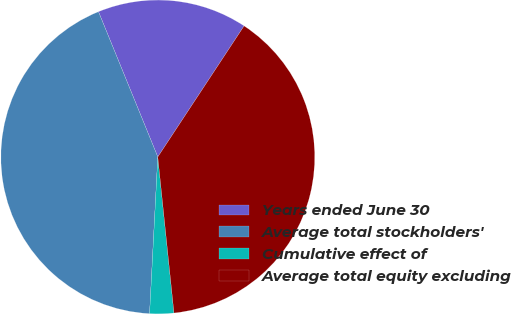Convert chart to OTSL. <chart><loc_0><loc_0><loc_500><loc_500><pie_chart><fcel>Years ended June 30<fcel>Average total stockholders'<fcel>Cumulative effect of<fcel>Average total equity excluding<nl><fcel>15.44%<fcel>43.0%<fcel>2.48%<fcel>39.09%<nl></chart> 